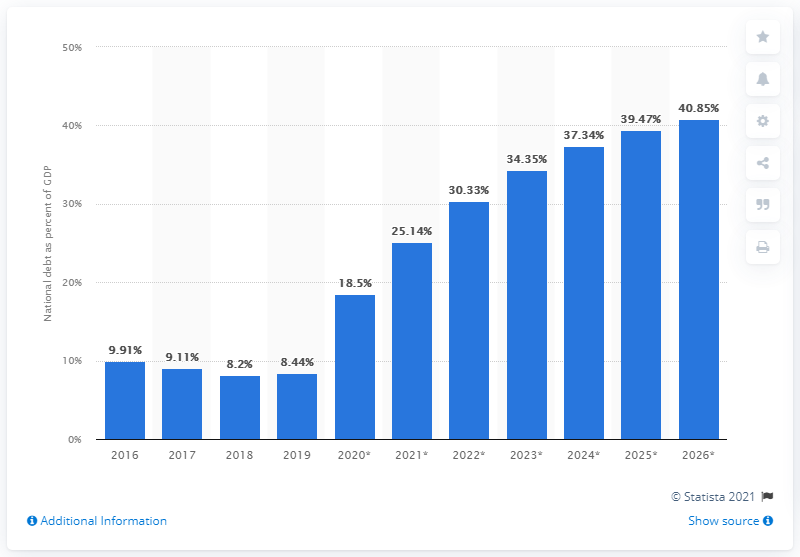What percentage of Estonia's GDP did the national debt amount to in 2019? In 2019, Estonia's national debt was 8.4% of its GDP, reflecting a relatively low debt-to-GDP ratio that indicates a solid fiscal position for the country. 